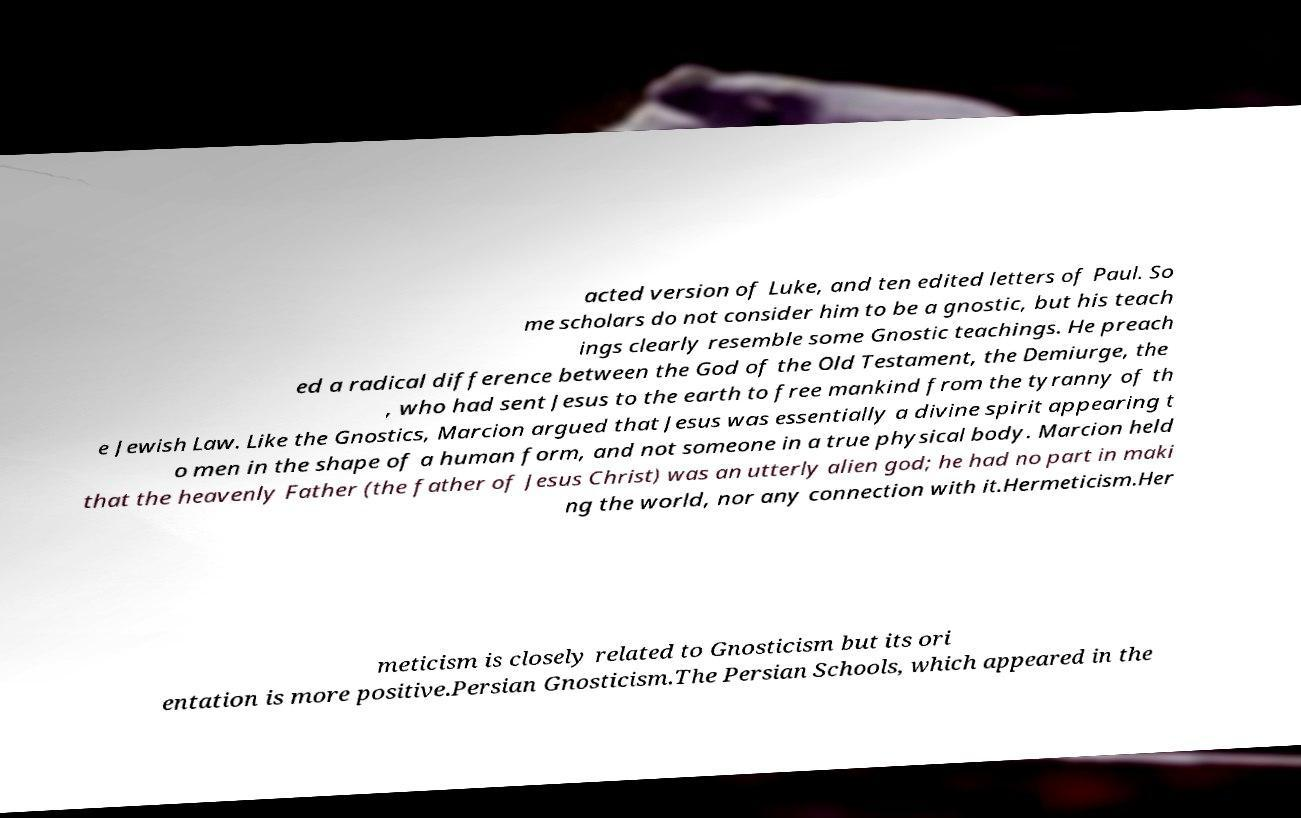Please read and relay the text visible in this image. What does it say? acted version of Luke, and ten edited letters of Paul. So me scholars do not consider him to be a gnostic, but his teach ings clearly resemble some Gnostic teachings. He preach ed a radical difference between the God of the Old Testament, the Demiurge, the , who had sent Jesus to the earth to free mankind from the tyranny of th e Jewish Law. Like the Gnostics, Marcion argued that Jesus was essentially a divine spirit appearing t o men in the shape of a human form, and not someone in a true physical body. Marcion held that the heavenly Father (the father of Jesus Christ) was an utterly alien god; he had no part in maki ng the world, nor any connection with it.Hermeticism.Her meticism is closely related to Gnosticism but its ori entation is more positive.Persian Gnosticism.The Persian Schools, which appeared in the 